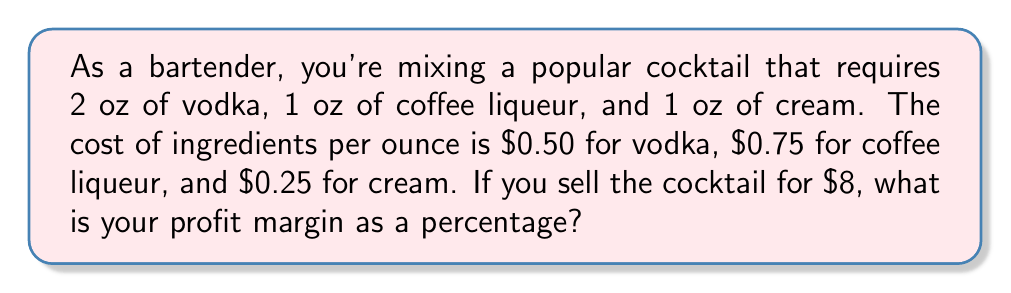Show me your answer to this math problem. Let's break this down step-by-step:

1) First, calculate the total cost of ingredients:
   - Vodka: $2 \text{ oz} \times \$0.50/\text{oz} = \$1.00$
   - Coffee liqueur: $1 \text{ oz} \times \$0.75/\text{oz} = \$0.75$
   - Cream: $1 \text{ oz} \times \$0.25/\text{oz} = \$0.25$
   
   Total cost: $\$1.00 + \$0.75 + \$0.25 = \$2.00$

2) The selling price is $8.00

3) Calculate the profit:
   $\text{Profit} = \text{Selling Price} - \text{Cost}$
   $\text{Profit} = \$8.00 - \$2.00 = \$6.00$

4) Calculate the profit margin as a percentage:
   $$\text{Profit Margin} = \frac{\text{Profit}}{\text{Selling Price}} \times 100\%$$
   
   $$\text{Profit Margin} = \frac{\$6.00}{\$8.00} \times 100\% = 0.75 \times 100\% = 75\%$$
Answer: The profit margin is 75%. 